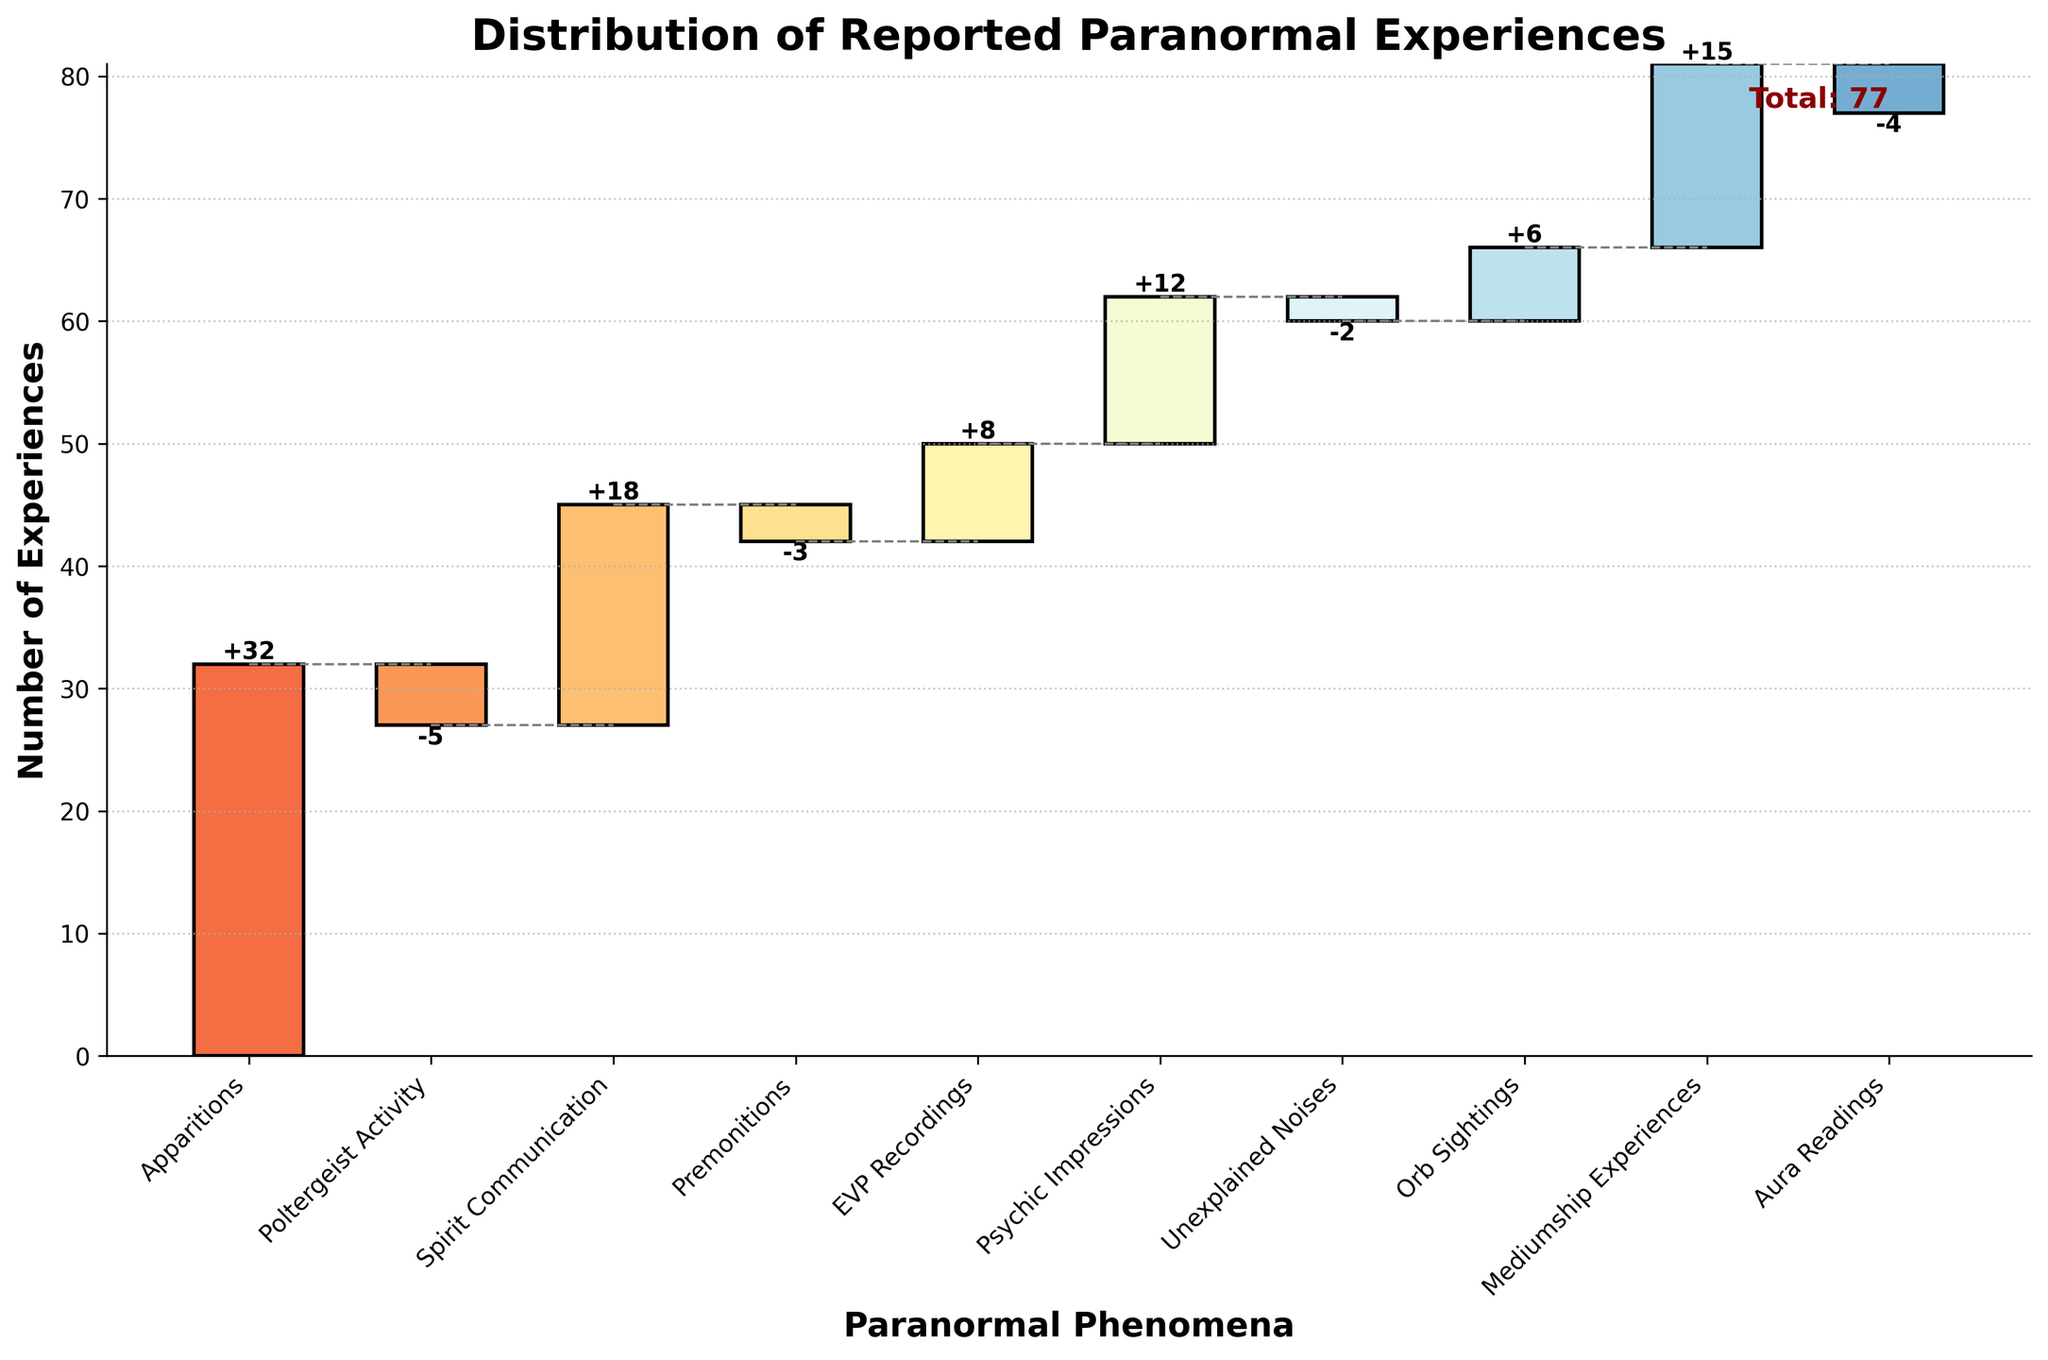What is the title of the chart? The title of the chart is displayed at the top of the figure.
Answer: Distribution of Reported Paranormal Experiences What are the categories on the x-axis? The x-axis labels represent different types of paranormal phenomena. These can be read along the x-axis at the bottom of the chart.
Answer: Apparitions, Poltergeist Activity, Spirit Communication, Premonitions, EVP Recordings, Psychic Impressions, Unexplained Noises, Orb Sightings, Mediumship Experiences, Aura Readings What does the y-axis represent? The y-axis indicates the number of reported experiences for each paranormal phenomenon. This is indicated by the axis label.
Answer: Number of Experiences Which category has the highest positive value? To identify the highest positive value, look at the values attached to the bars. The category with the largest upward bar represents the highest positive value.
Answer: Apparitions (32) What is the total value of all experiences reported? The total value is indicated at the end of the cumulative sum bar on the right, where it states "Total: 77".
Answer: 77 How many categories have negative values, and which are they? Count the number of bars that extend downward from the base line, indicating negative values, and list their categories.
Answer: Four categories: Poltergeist Activity, Premonitions, Unexplained Noises, Aura Readings Which category causes the largest drop in reported experiences? Examine the bar lengths pointing downwards, and identify the one with the largest magnitude.
Answer: Poltergeist Activity (-5) 